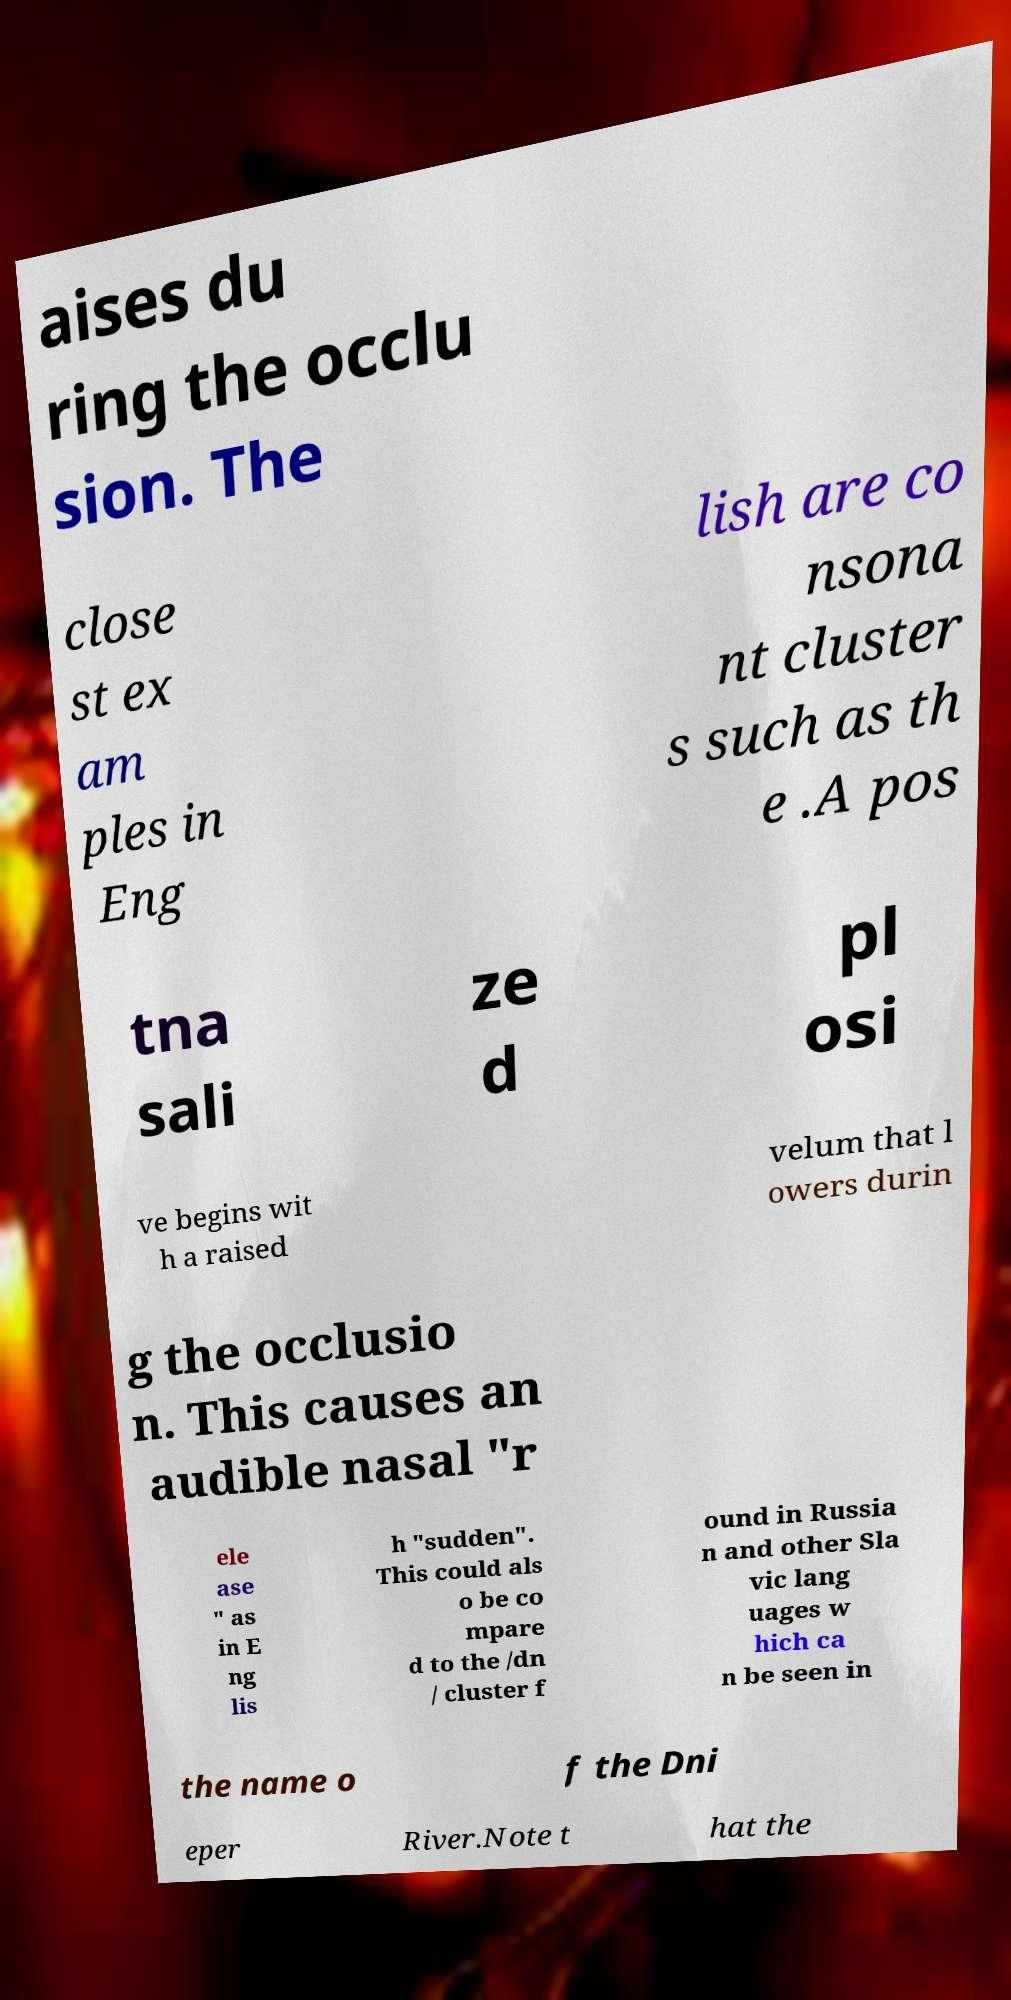There's text embedded in this image that I need extracted. Can you transcribe it verbatim? aises du ring the occlu sion. The close st ex am ples in Eng lish are co nsona nt cluster s such as th e .A pos tna sali ze d pl osi ve begins wit h a raised velum that l owers durin g the occlusio n. This causes an audible nasal "r ele ase " as in E ng lis h "sudden". This could als o be co mpare d to the /dn / cluster f ound in Russia n and other Sla vic lang uages w hich ca n be seen in the name o f the Dni eper River.Note t hat the 